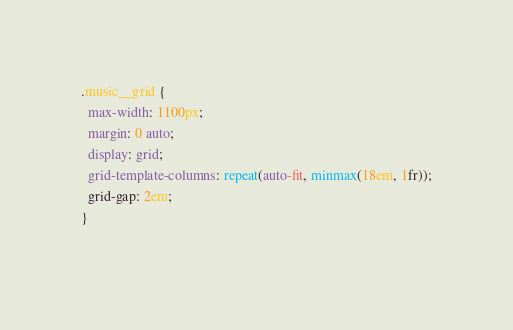Convert code to text. <code><loc_0><loc_0><loc_500><loc_500><_CSS_>.music__grid {
  max-width: 1100px;
  margin: 0 auto;
  display: grid;
  grid-template-columns: repeat(auto-fit, minmax(18em, 1fr));
  grid-gap: 2em;
}
  </code> 